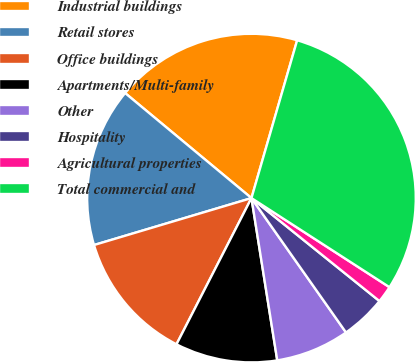Convert chart to OTSL. <chart><loc_0><loc_0><loc_500><loc_500><pie_chart><fcel>Industrial buildings<fcel>Retail stores<fcel>Office buildings<fcel>Apartments/Multi-family<fcel>Other<fcel>Hospitality<fcel>Agricultural properties<fcel>Total commercial and<nl><fcel>18.45%<fcel>15.65%<fcel>12.85%<fcel>10.05%<fcel>7.25%<fcel>4.46%<fcel>1.66%<fcel>29.64%<nl></chart> 